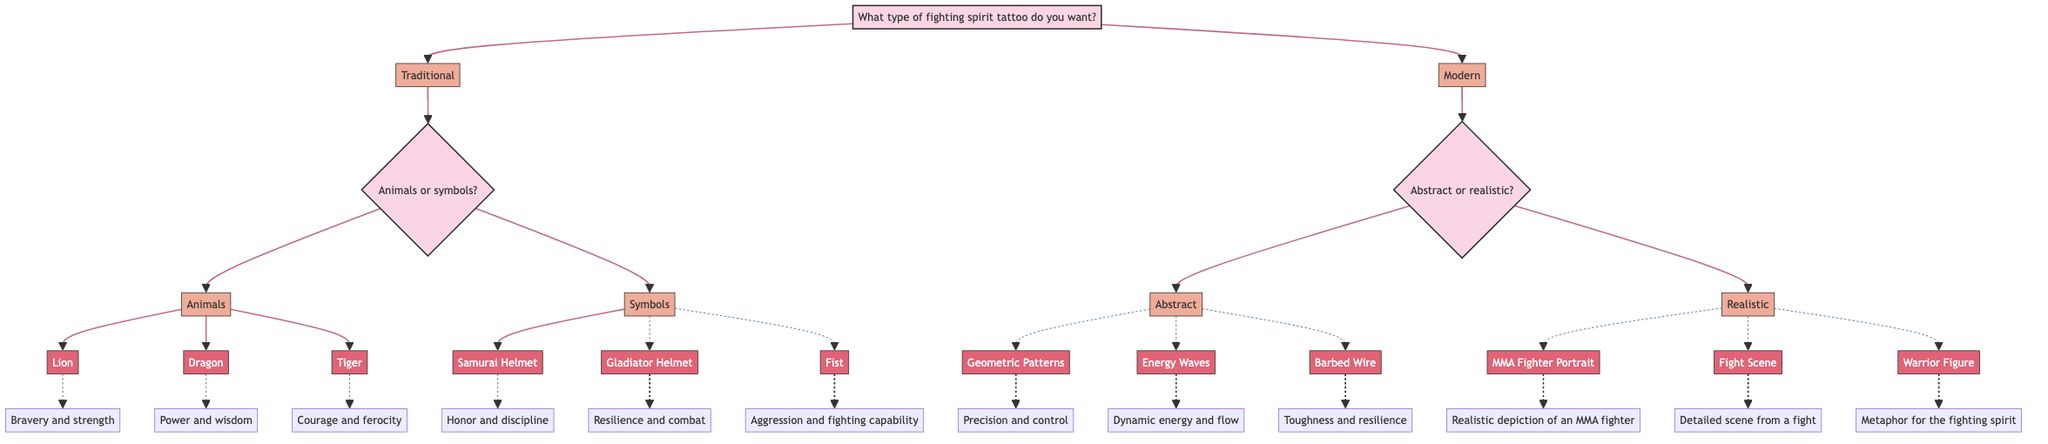What type of tattoo options are available under Traditional? According to the diagram, the options under Traditional are Animals and Symbols, as indicated by the first split from the main question about fighting spirit tattoos.
Answer: Animals, Symbols How many elements are listed under the Animals category? The diagram shows three elements under the Animals category: Lion, Dragon, and Tiger, as derived from the path that leads to this category.
Answer: 3 What is the description of the Fist element? The diagram indicates that the Fist represents aggression and fighting capability. This is found by following the path from Symbols to the Fist element.
Answer: Aggression and fighting capability What are the two subcategories under Modern design influences? The diagram displays that the options under Modern are Abstract and Realistic. This can be identified at the first decision point after choosing Modern.
Answer: Abstract, Realistic What does the Geometric Patterns element signify? According to the diagram, Geometric Patterns indicates precision and control. This can be confirmed by tracing the path to this specific element under the Abstract category.
Answer: Precision and control Which options correspond to Realistic designs? The diagram clearly shows that the options under Realistic designs are MMA Fighter Portrait, Fight Scene, and Warrior Figure. This can be traced back to the second question after Modern.
Answer: MMA Fighter Portrait, Fight Scene, Warrior Figure What element symbolizes toughness and resilience? Following the diagram, Barbed Wire is the element that symbolizes toughness and resilience, found within the Abstract design category.
Answer: Barbed Wire How many total choices are possible under the Traditional tattoo category? The diagram indicates that there are three choices under Animals and three choices under Symbols, giving a total of six choices under the Traditional category when combined.
Answer: 6 What is the type of question asked after selecting Modern in the diagram? The diagram shows that after selecting Modern, the next question is whether to choose Abstract or Realistic, giving a clear distinction between design styles.
Answer: Abstract or Realistic 